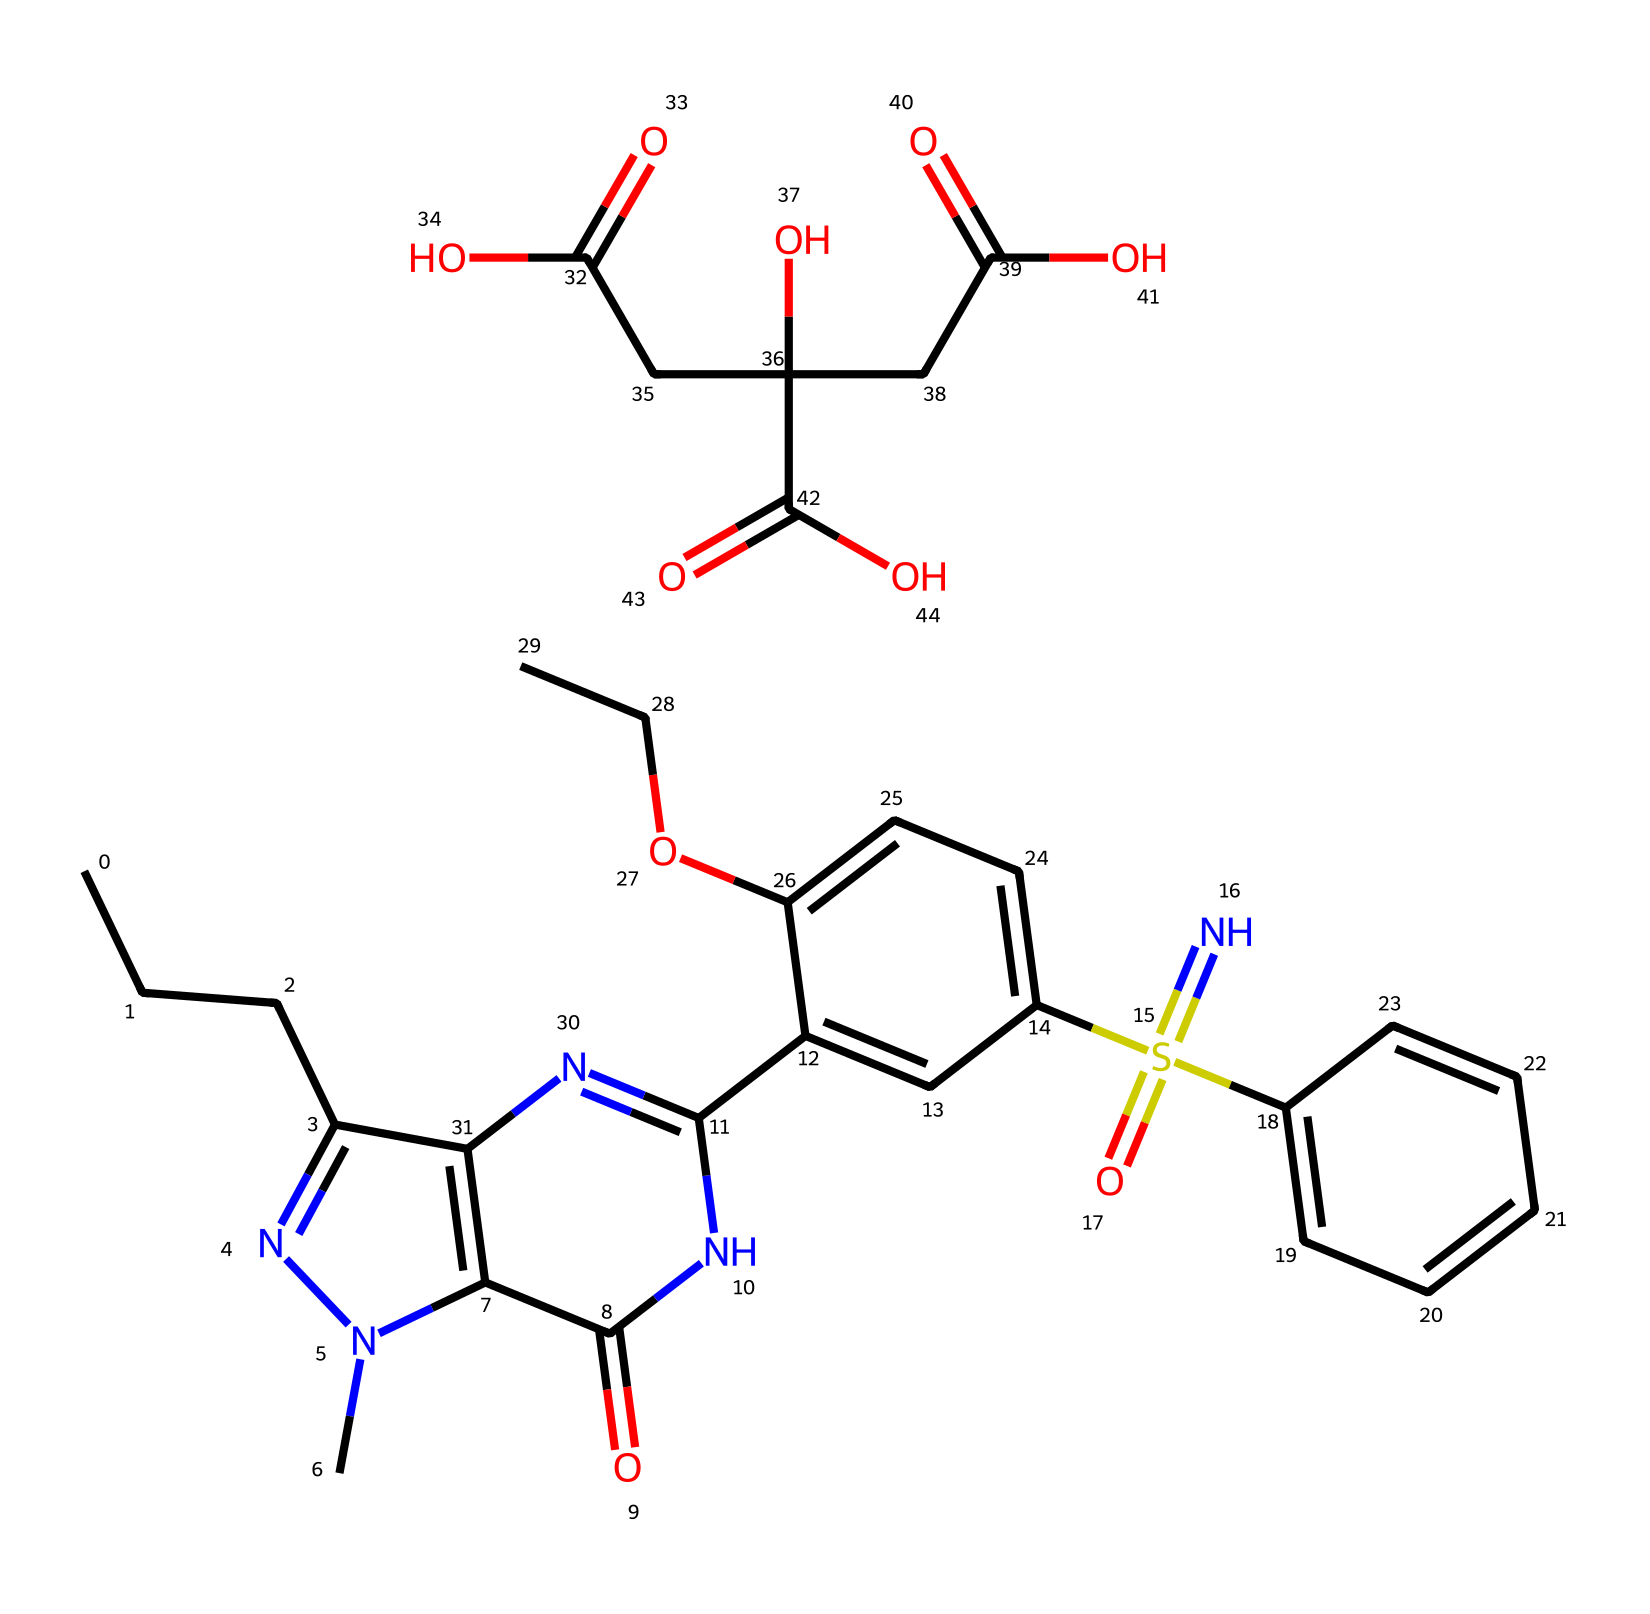What is the molecular formula of sildenafil citrate? The molecular formula can be deduced by counting the number of each type of atom represented in the SMILES. The formula consists of carbon (C), hydrogen (H), nitrogen (N), and oxygen (O). Counting all the atoms from the SMILES provides C22H30N6O4S
Answer: C22H30N6O4S How many nitrogen atoms are present in sildenafil citrate? In the structure represented by the SMILES, nitrogen atoms are denoted as 'N'. By examining the SMILES closely, we identify that there are six nitrogen (N) atoms present.
Answer: 6 What functional groups are identified in sildenafil citrate? By analyzing the SMILES, we can find multiple functional groups including carboxylic acid (-COOH), alcohol (-OH), and sulfonamide (S(=N)(=O)). Listing these gives us the functional groups present in the compound.
Answer: carboxylic acid, alcohol, sulfonamide Which atom in the molecule is part of a ring structure? The structure includes several ring systems identified in the SMILES where carbon and nitrogen atoms are arranged in a cyclic formation. Notably, both 'c' and 'n' letters indicate the ring portions.
Answer: nitrogen, carbon What is the significance of the sulfonamide group in sildenafil citrate? The sulfonamide group in the SMILES enhances the compound's pharmacological activity by modifying its interaction with biological targets, increasing its efficacy. This group contributes to the compound's solubility and pharmacokinetics.
Answer: increases solubility and efficacy How does the presence of multiple carbon chains affect the properties of sildenafil citrate? The presence of long carbon chains generally makes a compound more hydrophobic, which can affect how it is absorbed and distributed in the body. In sildenafil citrate, these chains contribute to its lipophilicity and impact its interaction with cellular membranes.
Answer: increases lipophilicity What role does the hydroxyl (-OH) group play in the activity of sildenafil citrate? The hydroxyl (-OH) group can serve as a hydrogen bond donor or acceptor, facilitating interactions with biological targets. This functional group enhances the overall activity of the drug through increased binding interaction with enzymes or receptors.
Answer: enhances binding interactions 